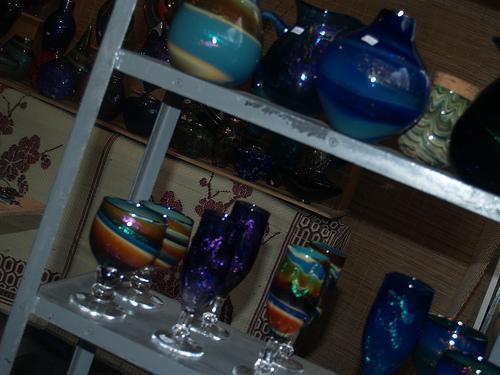How many purple glasses are there?
Give a very brief answer. 2. How many rugs are visible?
Give a very brief answer. 1. How many shelves are visible?
Give a very brief answer. 2. How many purple colored glasses are there?
Give a very brief answer. 2. How many price tags are visible?
Give a very brief answer. 2. How many multi colored glasses are there?
Give a very brief answer. 3. How many shelves are there?
Give a very brief answer. 2. 